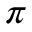Convert formula to latex. <formula><loc_0><loc_0><loc_500><loc_500>\pi</formula> 